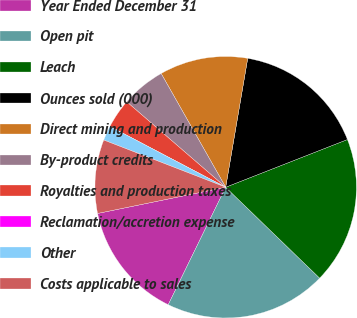Convert chart. <chart><loc_0><loc_0><loc_500><loc_500><pie_chart><fcel>Year Ended December 31<fcel>Open pit<fcel>Leach<fcel>Ounces sold (000)<fcel>Direct mining and production<fcel>By-product credits<fcel>Royalties and production taxes<fcel>Reclamation/accretion expense<fcel>Other<fcel>Costs applicable to sales<nl><fcel>14.55%<fcel>20.0%<fcel>18.18%<fcel>16.36%<fcel>10.91%<fcel>5.45%<fcel>3.64%<fcel>0.0%<fcel>1.82%<fcel>9.09%<nl></chart> 